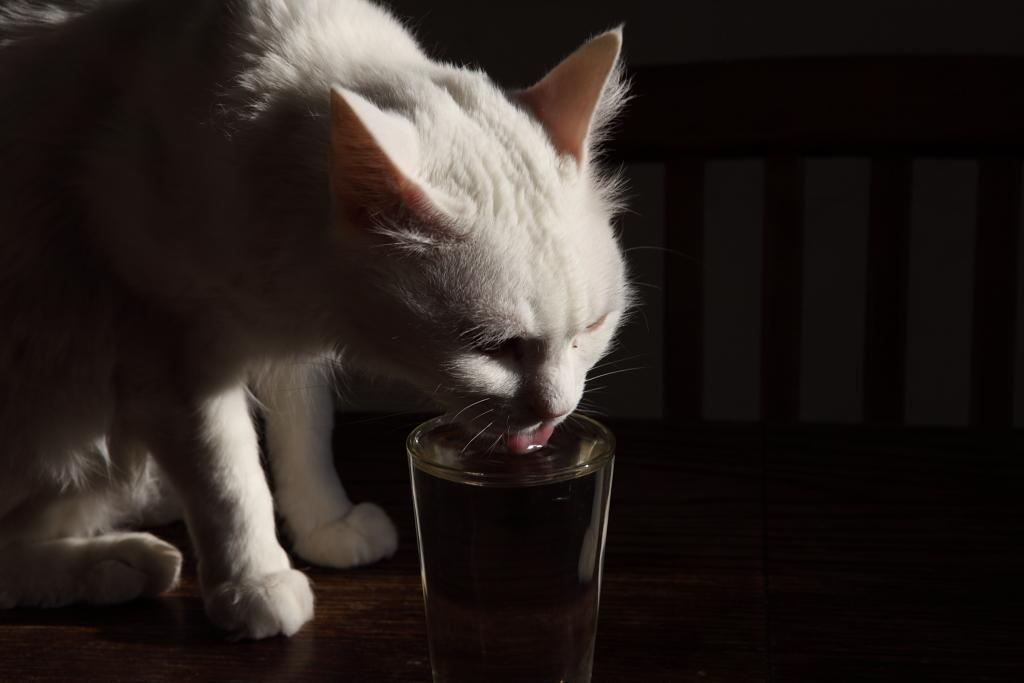What animal can be seen in the image? There is a cat in the image. What is the cat doing in the image? The cat is drinking water from a glass. What type of flooring is visible at the bottom of the image? There is wooden flooring at the bottom of the image. What type of underwear is the cat wearing in the image? There is no underwear visible in the image, as cats do not wear clothing. 